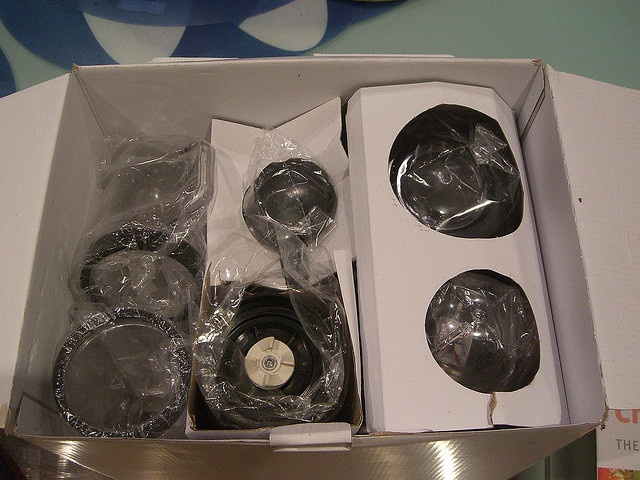Describe the objects in this image and their specific colors. I can see various objects in this image with different colors. 